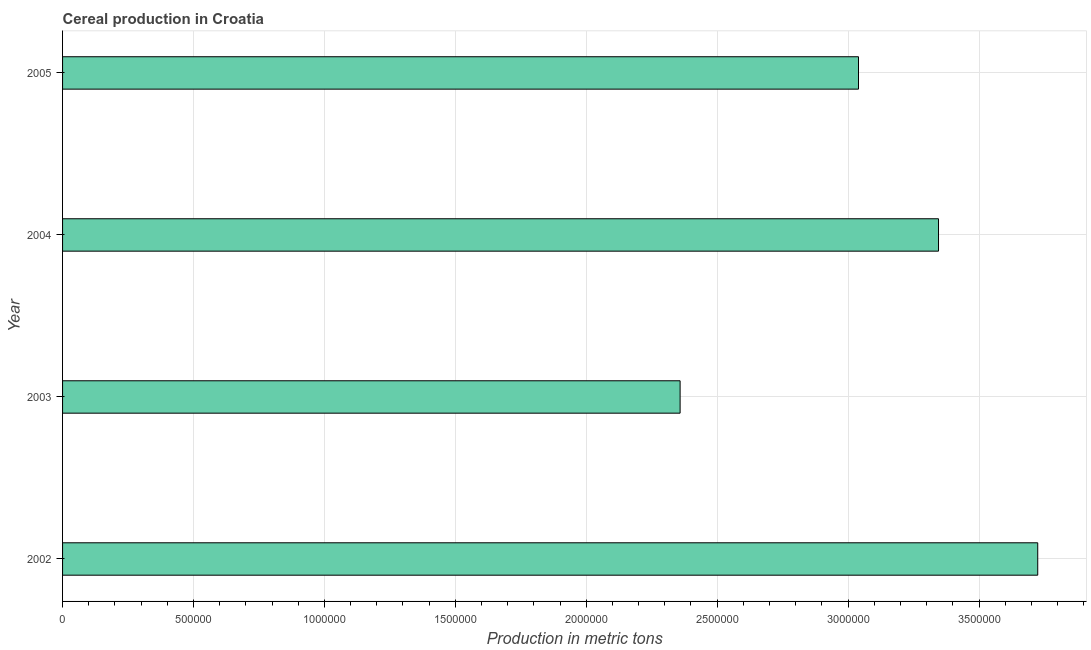Does the graph contain any zero values?
Make the answer very short. No. Does the graph contain grids?
Make the answer very short. Yes. What is the title of the graph?
Provide a short and direct response. Cereal production in Croatia. What is the label or title of the X-axis?
Offer a very short reply. Production in metric tons. What is the cereal production in 2002?
Your answer should be compact. 3.72e+06. Across all years, what is the maximum cereal production?
Make the answer very short. 3.72e+06. Across all years, what is the minimum cereal production?
Your answer should be very brief. 2.36e+06. In which year was the cereal production maximum?
Make the answer very short. 2002. In which year was the cereal production minimum?
Offer a very short reply. 2003. What is the sum of the cereal production?
Provide a short and direct response. 1.25e+07. What is the difference between the cereal production in 2002 and 2005?
Your answer should be very brief. 6.85e+05. What is the average cereal production per year?
Offer a very short reply. 3.12e+06. What is the median cereal production?
Keep it short and to the point. 3.19e+06. Do a majority of the years between 2002 and 2005 (inclusive) have cereal production greater than 400000 metric tons?
Offer a very short reply. Yes. What is the ratio of the cereal production in 2002 to that in 2004?
Make the answer very short. 1.11. Is the cereal production in 2002 less than that in 2004?
Your answer should be compact. No. What is the difference between the highest and the second highest cereal production?
Your answer should be very brief. 3.79e+05. What is the difference between the highest and the lowest cereal production?
Make the answer very short. 1.37e+06. What is the difference between two consecutive major ticks on the X-axis?
Your answer should be very brief. 5.00e+05. What is the Production in metric tons of 2002?
Keep it short and to the point. 3.72e+06. What is the Production in metric tons in 2003?
Make the answer very short. 2.36e+06. What is the Production in metric tons of 2004?
Your answer should be very brief. 3.35e+06. What is the Production in metric tons in 2005?
Your answer should be very brief. 3.04e+06. What is the difference between the Production in metric tons in 2002 and 2003?
Provide a succinct answer. 1.37e+06. What is the difference between the Production in metric tons in 2002 and 2004?
Your response must be concise. 3.79e+05. What is the difference between the Production in metric tons in 2002 and 2005?
Offer a very short reply. 6.85e+05. What is the difference between the Production in metric tons in 2003 and 2004?
Your answer should be compact. -9.87e+05. What is the difference between the Production in metric tons in 2003 and 2005?
Keep it short and to the point. -6.81e+05. What is the difference between the Production in metric tons in 2004 and 2005?
Offer a terse response. 3.06e+05. What is the ratio of the Production in metric tons in 2002 to that in 2003?
Give a very brief answer. 1.58. What is the ratio of the Production in metric tons in 2002 to that in 2004?
Ensure brevity in your answer.  1.11. What is the ratio of the Production in metric tons in 2002 to that in 2005?
Offer a terse response. 1.23. What is the ratio of the Production in metric tons in 2003 to that in 2004?
Keep it short and to the point. 0.7. What is the ratio of the Production in metric tons in 2003 to that in 2005?
Keep it short and to the point. 0.78. What is the ratio of the Production in metric tons in 2004 to that in 2005?
Make the answer very short. 1.1. 